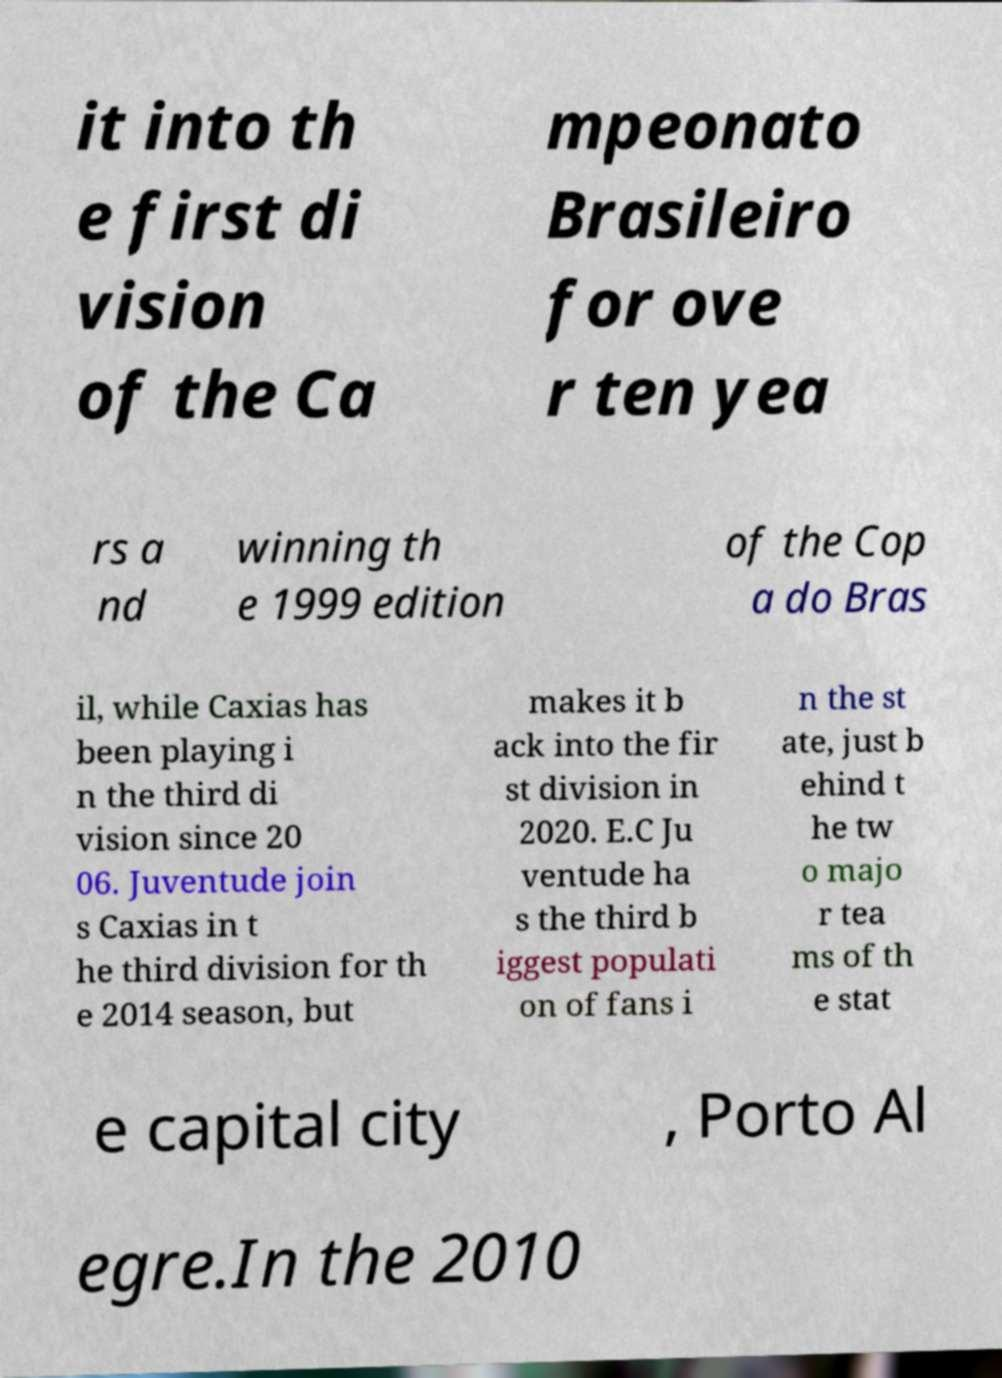I need the written content from this picture converted into text. Can you do that? it into th e first di vision of the Ca mpeonato Brasileiro for ove r ten yea rs a nd winning th e 1999 edition of the Cop a do Bras il, while Caxias has been playing i n the third di vision since 20 06. Juventude join s Caxias in t he third division for th e 2014 season, but makes it b ack into the fir st division in 2020. E.C Ju ventude ha s the third b iggest populati on of fans i n the st ate, just b ehind t he tw o majo r tea ms of th e stat e capital city , Porto Al egre.In the 2010 